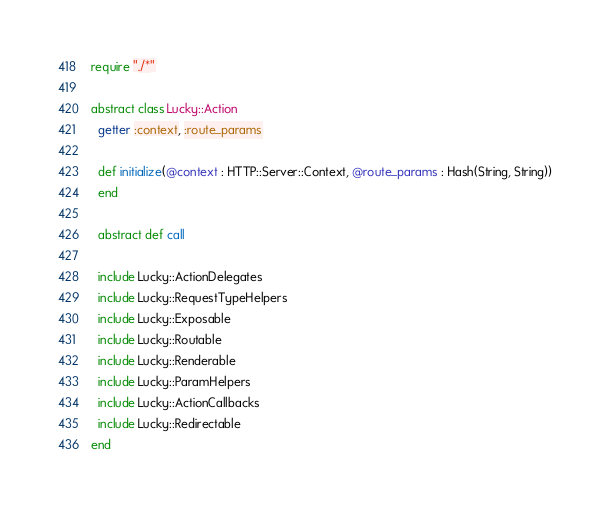<code> <loc_0><loc_0><loc_500><loc_500><_Crystal_>require "./*"

abstract class Lucky::Action
  getter :context, :route_params

  def initialize(@context : HTTP::Server::Context, @route_params : Hash(String, String))
  end

  abstract def call

  include Lucky::ActionDelegates
  include Lucky::RequestTypeHelpers
  include Lucky::Exposable
  include Lucky::Routable
  include Lucky::Renderable
  include Lucky::ParamHelpers
  include Lucky::ActionCallbacks
  include Lucky::Redirectable
end
</code> 